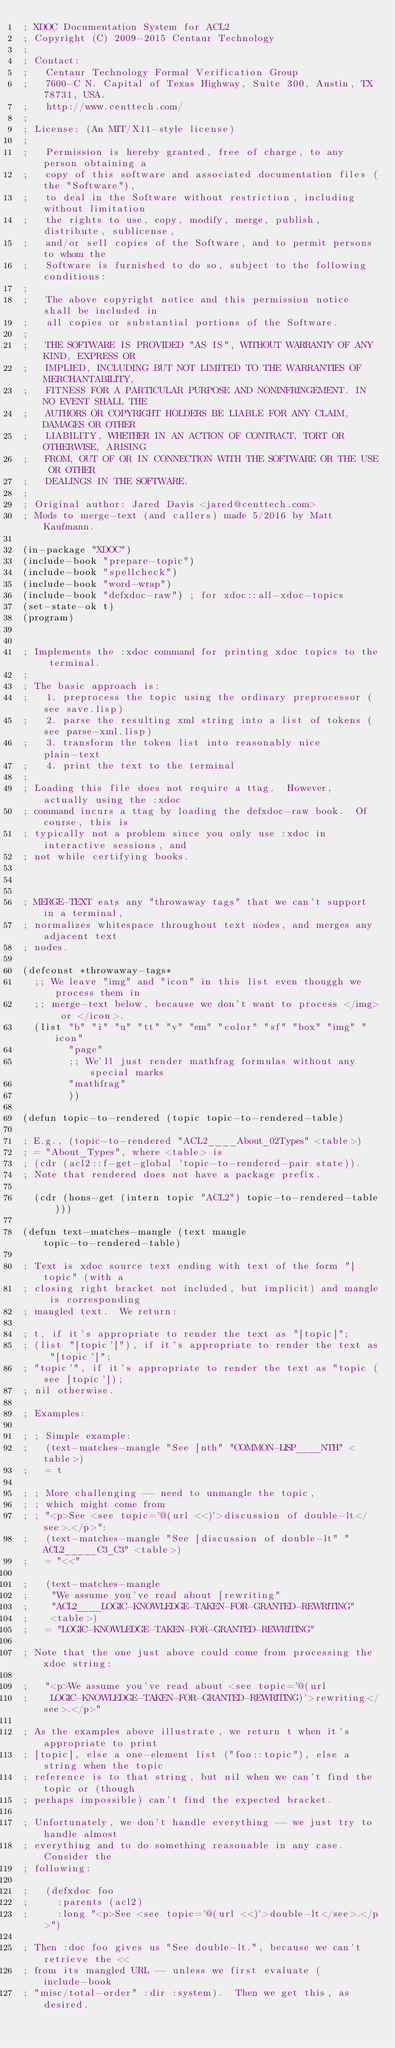<code> <loc_0><loc_0><loc_500><loc_500><_Lisp_>; XDOC Documentation System for ACL2
; Copyright (C) 2009-2015 Centaur Technology
;
; Contact:
;   Centaur Technology Formal Verification Group
;   7600-C N. Capital of Texas Highway, Suite 300, Austin, TX 78731, USA.
;   http://www.centtech.com/
;
; License: (An MIT/X11-style license)
;
;   Permission is hereby granted, free of charge, to any person obtaining a
;   copy of this software and associated documentation files (the "Software"),
;   to deal in the Software without restriction, including without limitation
;   the rights to use, copy, modify, merge, publish, distribute, sublicense,
;   and/or sell copies of the Software, and to permit persons to whom the
;   Software is furnished to do so, subject to the following conditions:
;
;   The above copyright notice and this permission notice shall be included in
;   all copies or substantial portions of the Software.
;
;   THE SOFTWARE IS PROVIDED "AS IS", WITHOUT WARRANTY OF ANY KIND, EXPRESS OR
;   IMPLIED, INCLUDING BUT NOT LIMITED TO THE WARRANTIES OF MERCHANTABILITY,
;   FITNESS FOR A PARTICULAR PURPOSE AND NONINFRINGEMENT. IN NO EVENT SHALL THE
;   AUTHORS OR COPYRIGHT HOLDERS BE LIABLE FOR ANY CLAIM, DAMAGES OR OTHER
;   LIABILITY, WHETHER IN AN ACTION OF CONTRACT, TORT OR OTHERWISE, ARISING
;   FROM, OUT OF OR IN CONNECTION WITH THE SOFTWARE OR THE USE OR OTHER
;   DEALINGS IN THE SOFTWARE.
;
; Original author: Jared Davis <jared@centtech.com>
; Mods to merge-text (and callers) made 5/2016 by Matt Kaufmann.

(in-package "XDOC")
(include-book "prepare-topic")
(include-book "spellcheck")
(include-book "word-wrap")
(include-book "defxdoc-raw") ; for xdoc::all-xdoc-topics
(set-state-ok t)
(program)


; Implements the :xdoc command for printing xdoc topics to the terminal.
;
; The basic approach is:
;   1. preprocess the topic using the ordinary preprocessor (see save.lisp)
;   2. parse the resulting xml string into a list of tokens (see parse-xml.lisp)
;   3. transform the token list into reasonably nice plain-text
;   4. print the text to the terminal
;
; Loading this file does not require a ttag.  However, actually using the :xdoc
; command incurs a ttag by loading the defxdoc-raw book.  Of course, this is
; typically not a problem since you only use :xdoc in interactive sessions, and
; not while certifying books.



; MERGE-TEXT eats any "throwaway tags" that we can't support in a terminal,
; normalizes whitespace throughout text nodes, and merges any adjacent text
; nodes.

(defconst *throwaway-tags*
  ;; We leave "img" and "icon" in this list even thouggh we process them in
  ;; merge-text below, because we don't want to process </img> or </icon>.
  (list "b" "i" "u" "tt" "v" "em" "color" "sf" "box" "img" "icon"
        "page"
        ;; We'll just render mathfrag formulas without any special marks
        "mathfrag"
        ))

(defun topic-to-rendered (topic topic-to-rendered-table)

; E.g., (topic-to-rendered "ACL2____About_02Types" <table>)
; = "About_Types", where <table> is
; (cdr (acl2::f-get-global 'topic-to-rendered-pair state)).
; Note that rendered does not have a package prefix.

  (cdr (hons-get (intern topic "ACL2") topic-to-rendered-table)))

(defun text-matches-mangle (text mangle topic-to-rendered-table)

; Text is xdoc source text ending with text of the form "[topic" (with a
; closing right bracket not included, but implicit) and mangle is corresponding
; mangled text.  We return:

; t, if it's appropriate to render the text as "[topic]";
; (list "[topic']"), if it's appropriate to render the text as "[topic']";
; "topic'", if it's appropriate to render the text as "topic (see [topic']);
; nil otherwise.

; Examples:

; ; Simple example:
;   (text-matches-mangle "See [nth" "COMMON-LISP____NTH" <table>)
;   = t

; ; More challenging -- need to unmangle the topic,
; ; which might come from
; ; "<p>See <see topic='@(url <<)'>discussion of double-lt</see>.</p>":
;   (text-matches-mangle "See [discussion of double-lt" "ACL2_____C3_C3" <table>)
;   = "<<"

;   (text-matches-mangle
;    "We assume you've read about [rewriting"
;    "ACL2____LOGIC-KNOWLEDGE-TAKEN-FOR-GRANTED-REWRITING"
;    <table>)
;   = "LOGIC-KNOWLEDGE-TAKEN-FOR-GRANTED-REWRITING"

; Note that the one just above could come from processing the xdoc string:

;   "<p>We assume you've read about <see topic='@(url
;    LOGIC-KNOWLEDGE-TAKEN-FOR-GRANTED-REWRITING)'>rewriting</see>.</p>"

; As the examples above illustrate, we return t when it's appropriate to print
; [topic], else a one-element list ("foo::topic"), else a string when the topic
; reference is to that string, but nil when we can't find the topic or (though
; perhaps impossible) can't find the expected bracket.

; Unfortunately, we don't handle everything -- we just try to handle almost
; everything and to do something reasonable in any case.  Consider the
; following:

;   (defxdoc foo
;     :parents (acl2)
;     :long "<p>See <see topic='@(url <<)'>double-lt</see>.</p>")

; Then :doc foo gives us "See double-lt.", because we can't retrieve the <<
; from its mangled URL -- unless we first evaluate (include-book
; "misc/total-order" :dir :system).  Then we get this, as desired.
</code> 